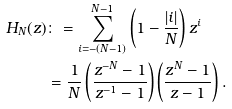<formula> <loc_0><loc_0><loc_500><loc_500>H _ { N } ( z ) & \colon = \sum _ { i = - ( N - 1 ) } ^ { N - 1 } \left ( 1 - \frac { | i | } { N } \right ) z ^ { i } \\ & = \frac { 1 } { N } \left ( \frac { z ^ { - N } - 1 } { z ^ { - 1 } - 1 } \right ) \left ( \frac { z ^ { N } - 1 } { z - 1 } \right ) .</formula> 